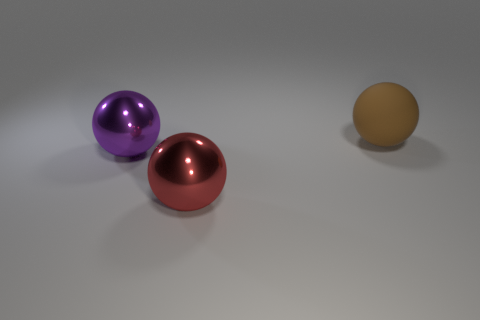Add 1 small red objects. How many objects exist? 4 Subtract all brown spheres. How many spheres are left? 2 Subtract all big brown spheres. How many spheres are left? 2 Subtract 0 cyan cylinders. How many objects are left? 3 Subtract 3 spheres. How many spheres are left? 0 Subtract all gray balls. Subtract all red cubes. How many balls are left? 3 Subtract all cyan cubes. How many red spheres are left? 1 Subtract all big green shiny things. Subtract all big brown matte spheres. How many objects are left? 2 Add 3 big red metal balls. How many big red metal balls are left? 4 Add 3 green balls. How many green balls exist? 3 